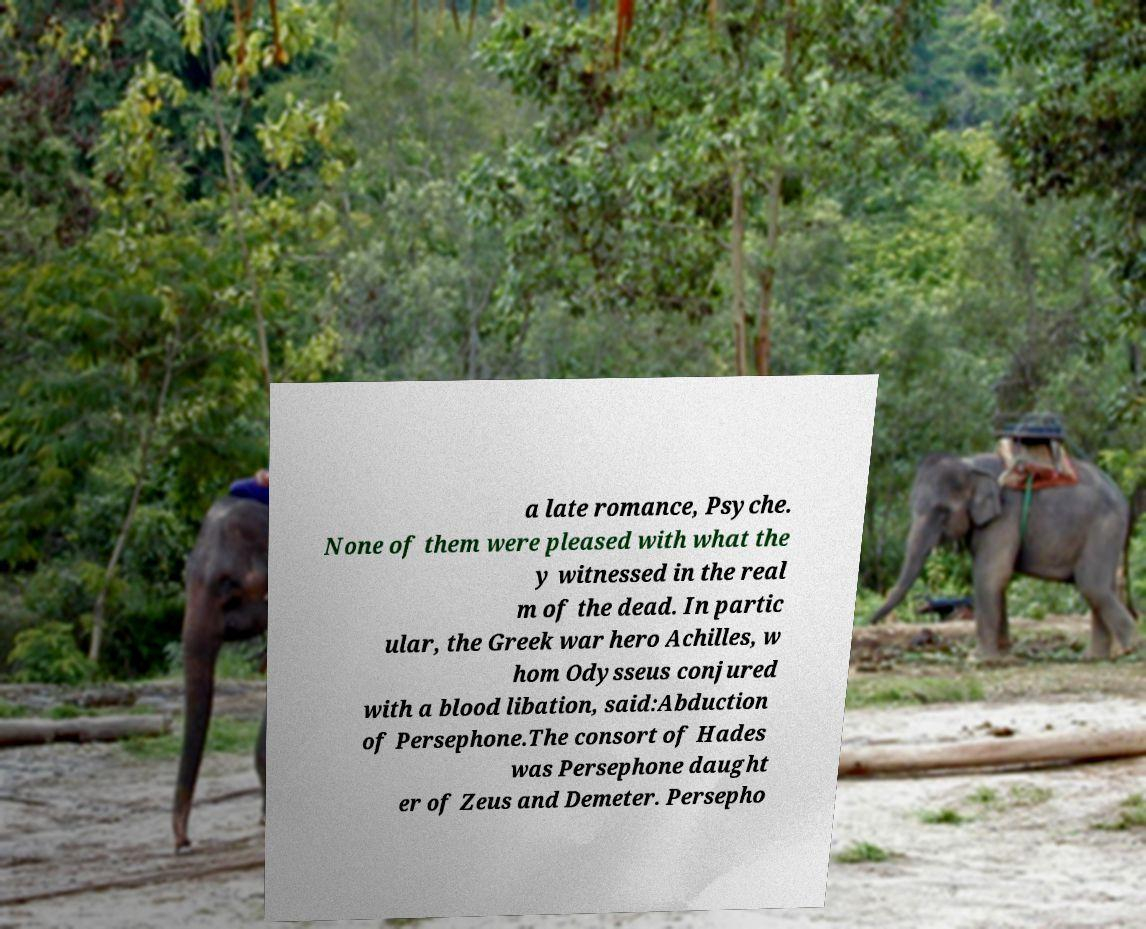What messages or text are displayed in this image? I need them in a readable, typed format. a late romance, Psyche. None of them were pleased with what the y witnessed in the real m of the dead. In partic ular, the Greek war hero Achilles, w hom Odysseus conjured with a blood libation, said:Abduction of Persephone.The consort of Hades was Persephone daught er of Zeus and Demeter. Persepho 